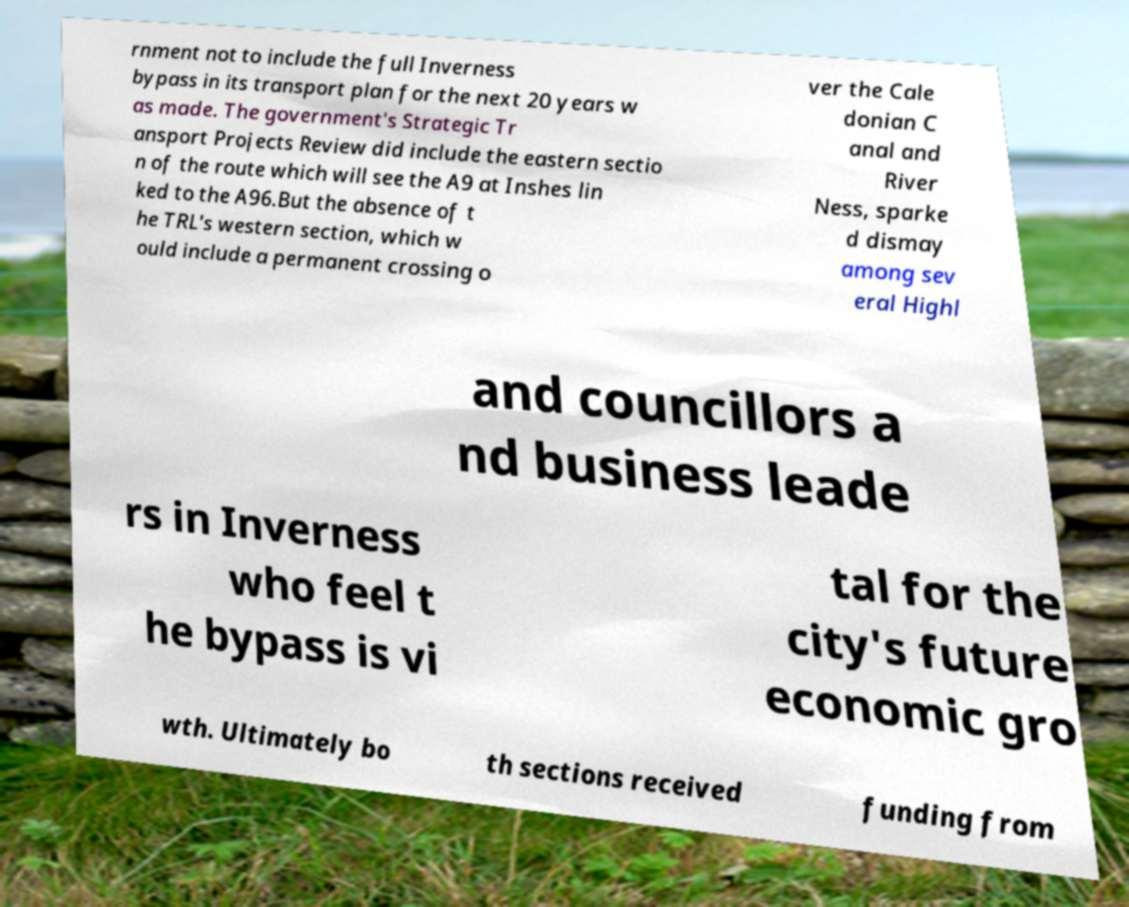Can you read and provide the text displayed in the image?This photo seems to have some interesting text. Can you extract and type it out for me? rnment not to include the full Inverness bypass in its transport plan for the next 20 years w as made. The government's Strategic Tr ansport Projects Review did include the eastern sectio n of the route which will see the A9 at Inshes lin ked to the A96.But the absence of t he TRL's western section, which w ould include a permanent crossing o ver the Cale donian C anal and River Ness, sparke d dismay among sev eral Highl and councillors a nd business leade rs in Inverness who feel t he bypass is vi tal for the city's future economic gro wth. Ultimately bo th sections received funding from 